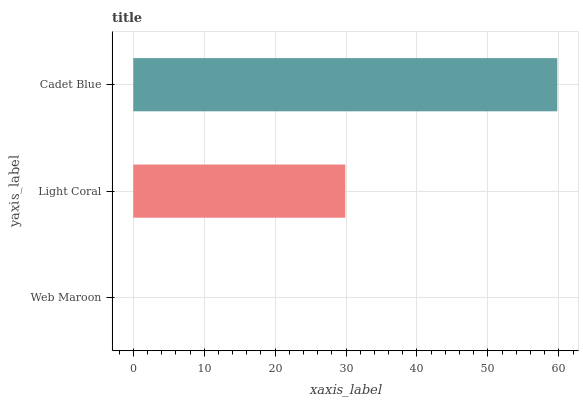Is Web Maroon the minimum?
Answer yes or no. Yes. Is Cadet Blue the maximum?
Answer yes or no. Yes. Is Light Coral the minimum?
Answer yes or no. No. Is Light Coral the maximum?
Answer yes or no. No. Is Light Coral greater than Web Maroon?
Answer yes or no. Yes. Is Web Maroon less than Light Coral?
Answer yes or no. Yes. Is Web Maroon greater than Light Coral?
Answer yes or no. No. Is Light Coral less than Web Maroon?
Answer yes or no. No. Is Light Coral the high median?
Answer yes or no. Yes. Is Light Coral the low median?
Answer yes or no. Yes. Is Cadet Blue the high median?
Answer yes or no. No. Is Web Maroon the low median?
Answer yes or no. No. 